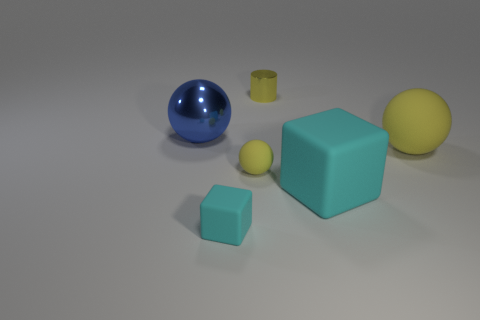Add 1 shiny objects. How many objects exist? 7 Subtract all cylinders. How many objects are left? 5 Subtract all blue objects. Subtract all yellow objects. How many objects are left? 2 Add 3 yellow metal cylinders. How many yellow metal cylinders are left? 4 Add 3 tiny yellow balls. How many tiny yellow balls exist? 4 Subtract 1 yellow spheres. How many objects are left? 5 